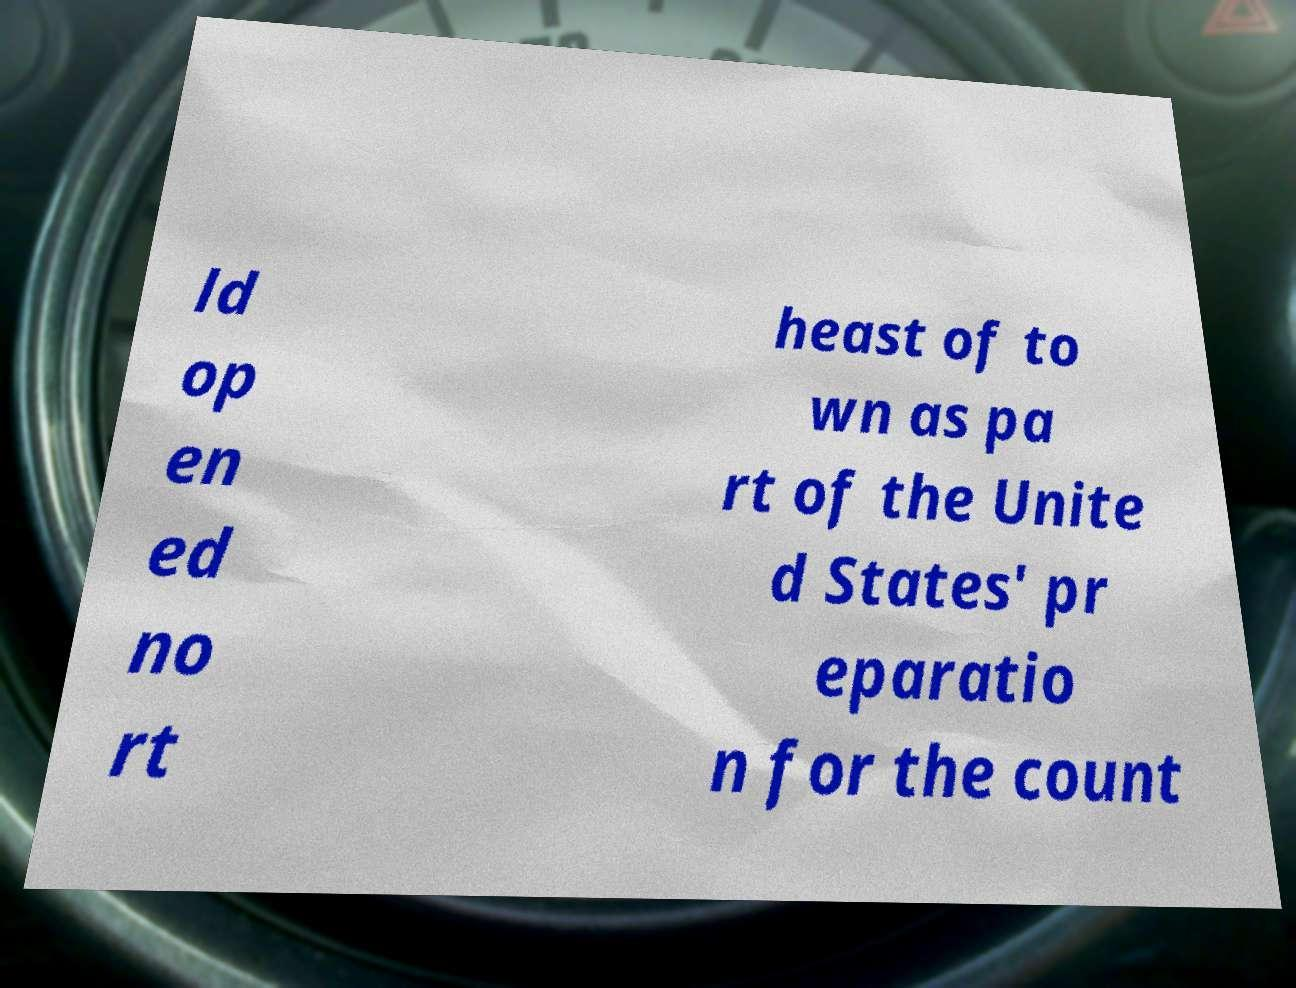Can you accurately transcribe the text from the provided image for me? ld op en ed no rt heast of to wn as pa rt of the Unite d States' pr eparatio n for the count 